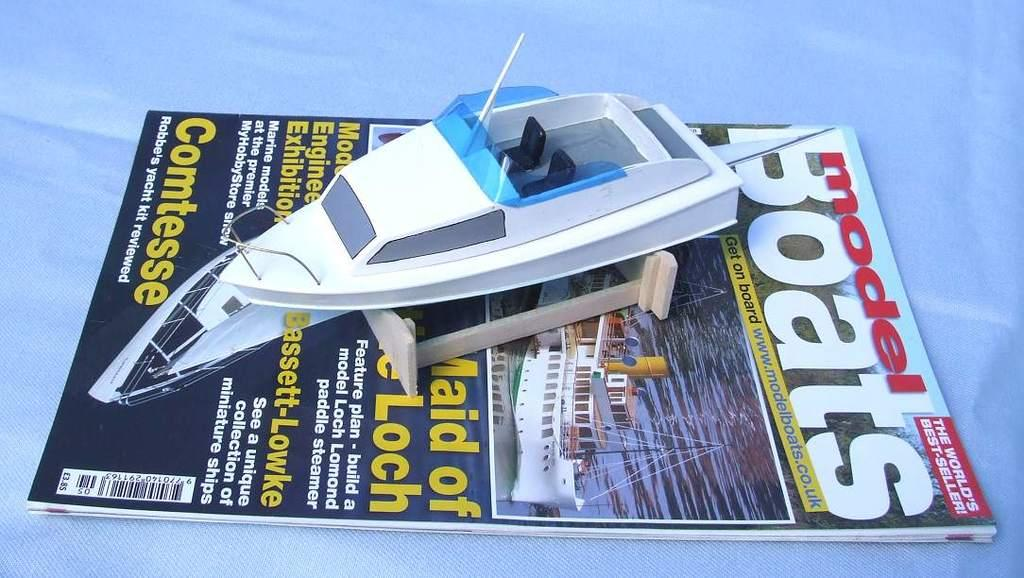<image>
Provide a brief description of the given image. A magazine about Model Boats with a model boat on top of it. 